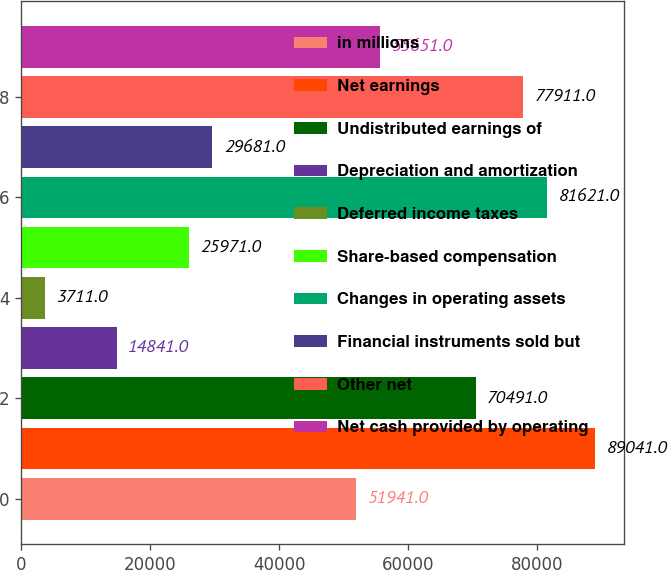<chart> <loc_0><loc_0><loc_500><loc_500><bar_chart><fcel>in millions<fcel>Net earnings<fcel>Undistributed earnings of<fcel>Depreciation and amortization<fcel>Deferred income taxes<fcel>Share-based compensation<fcel>Changes in operating assets<fcel>Financial instruments sold but<fcel>Other net<fcel>Net cash provided by operating<nl><fcel>51941<fcel>89041<fcel>70491<fcel>14841<fcel>3711<fcel>25971<fcel>81621<fcel>29681<fcel>77911<fcel>55651<nl></chart> 